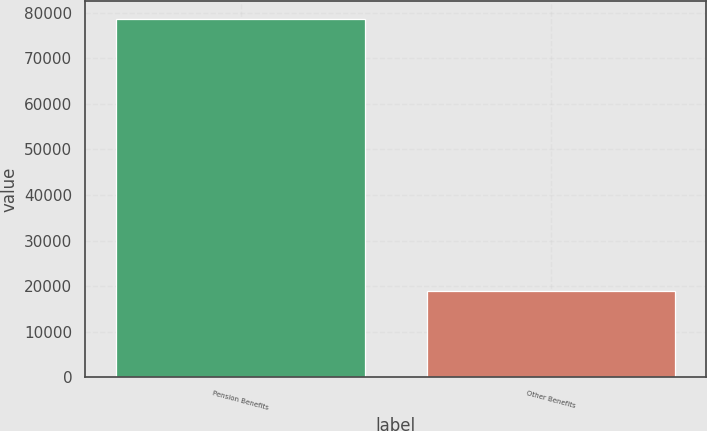Convert chart. <chart><loc_0><loc_0><loc_500><loc_500><bar_chart><fcel>Pension Benefits<fcel>Other Benefits<nl><fcel>78614<fcel>19026<nl></chart> 